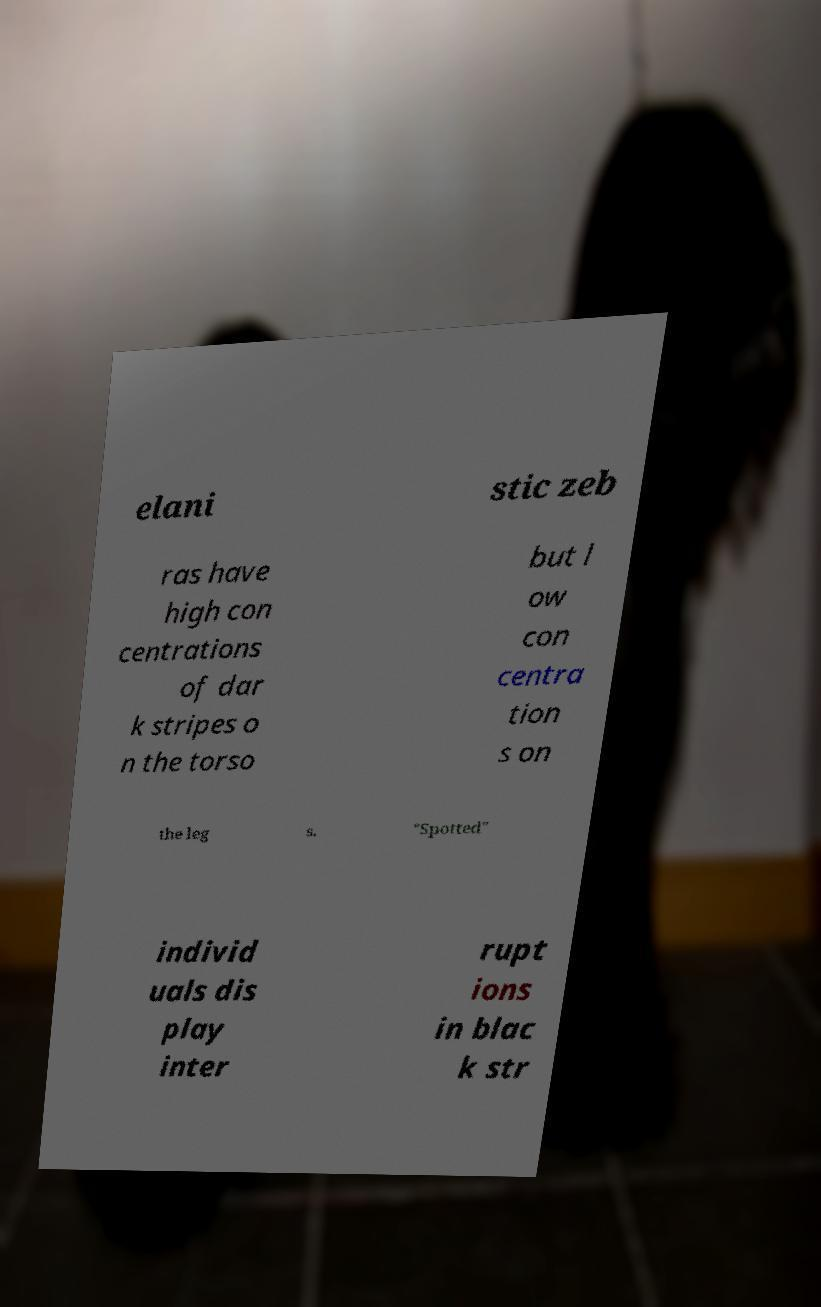I need the written content from this picture converted into text. Can you do that? elani stic zeb ras have high con centrations of dar k stripes o n the torso but l ow con centra tion s on the leg s. "Spotted" individ uals dis play inter rupt ions in blac k str 